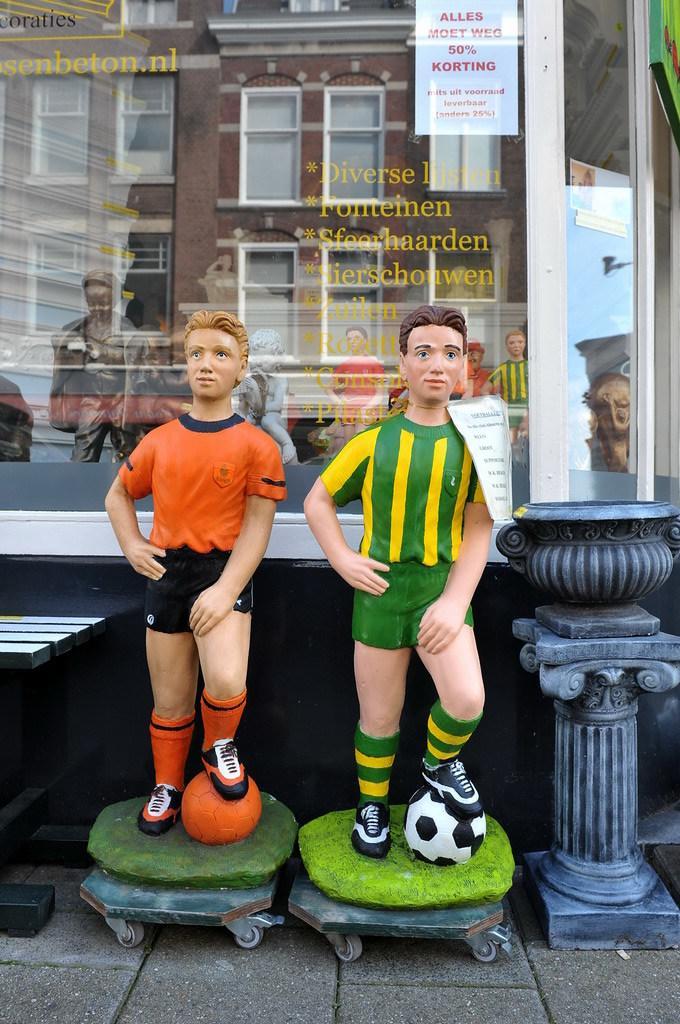In one or two sentences, can you explain what this image depicts? In the picture we can see a two statues of the foot ball players and standing and keeping a leg on the balls and they are on some plank with wheels to it and placed near the glass wall with a building image and some wordings on it. 